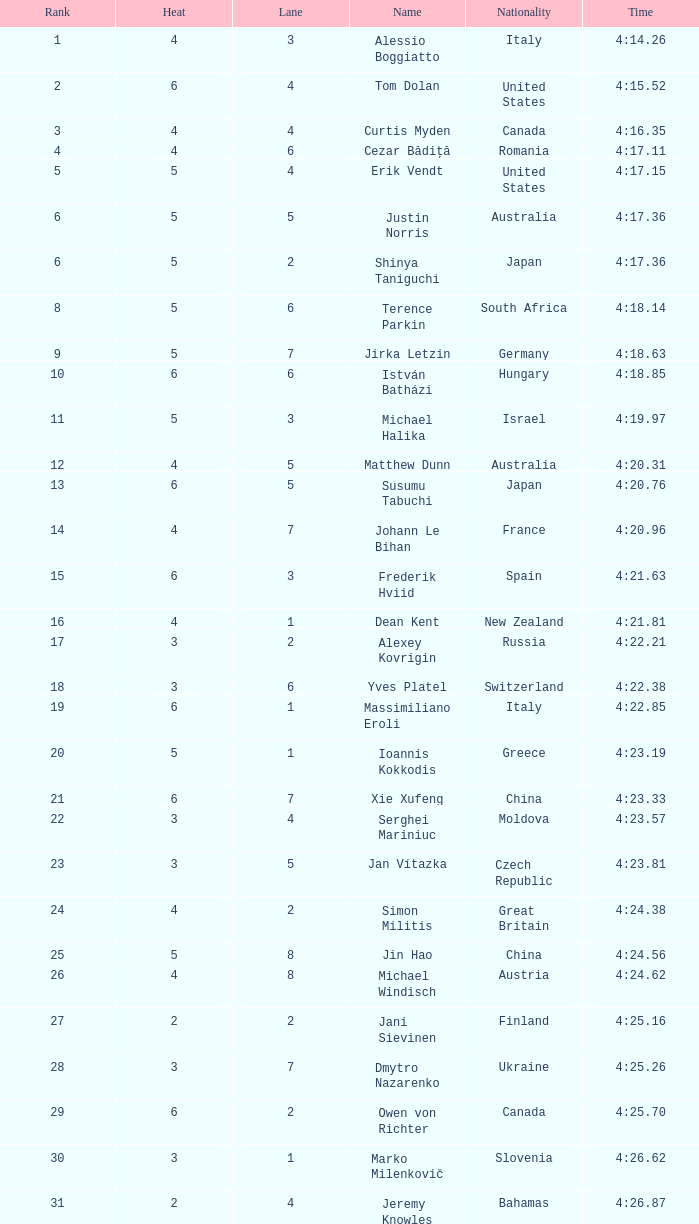Who was the 4 lane person from Canada? 4.0. 